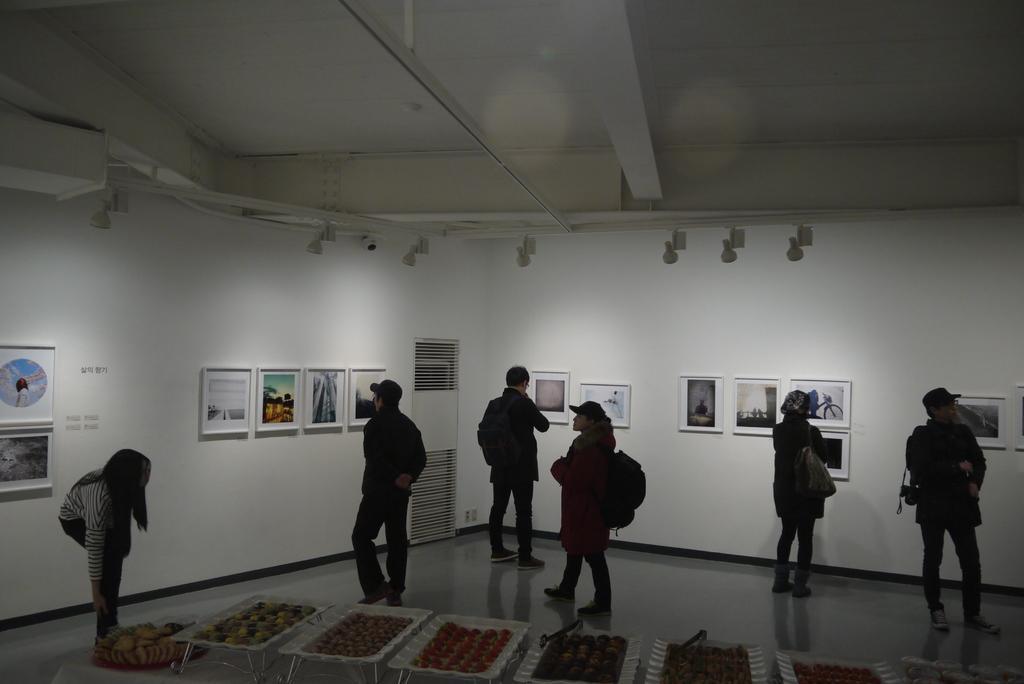In one or two sentences, can you explain what this image depicts? In this picture I can see there are a group of people standing and there is a table here and there is some food placed on the table. The people are looking to the photo frames placed on the wall and there are lights attached to the ceiling and there is a camera attached to the ceiling. 